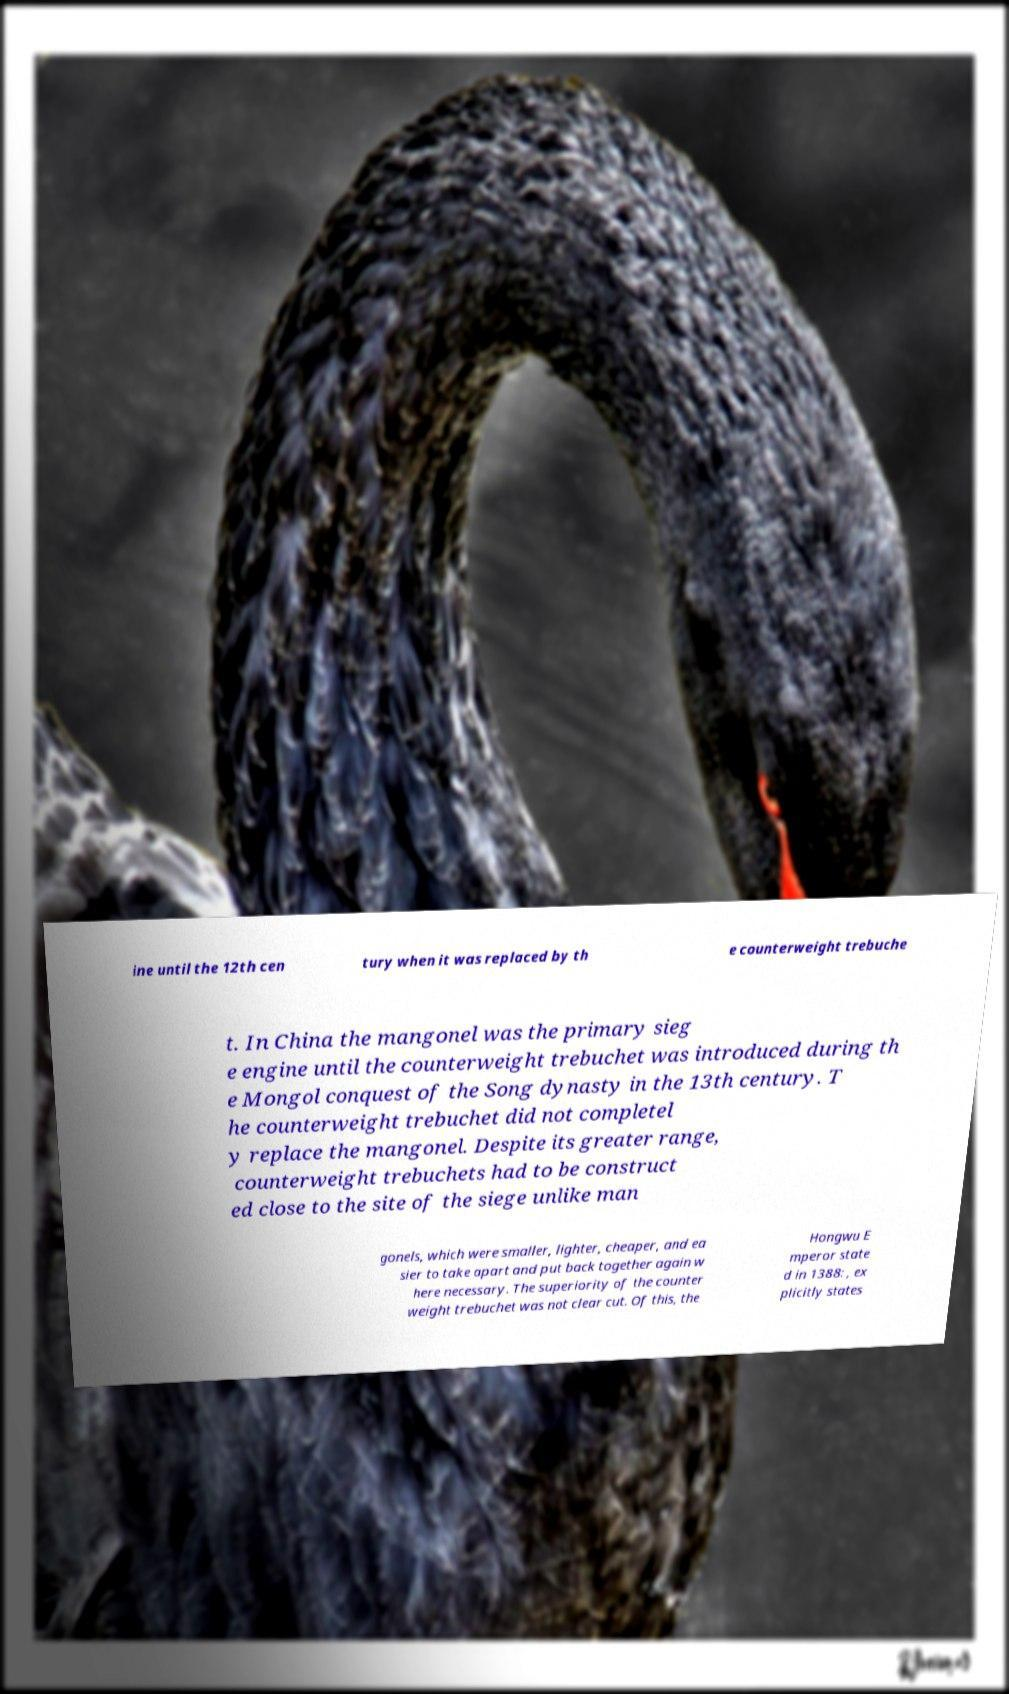Could you assist in decoding the text presented in this image and type it out clearly? ine until the 12th cen tury when it was replaced by th e counterweight trebuche t. In China the mangonel was the primary sieg e engine until the counterweight trebuchet was introduced during th e Mongol conquest of the Song dynasty in the 13th century. T he counterweight trebuchet did not completel y replace the mangonel. Despite its greater range, counterweight trebuchets had to be construct ed close to the site of the siege unlike man gonels, which were smaller, lighter, cheaper, and ea sier to take apart and put back together again w here necessary. The superiority of the counter weight trebuchet was not clear cut. Of this, the Hongwu E mperor state d in 1388: , ex plicitly states 